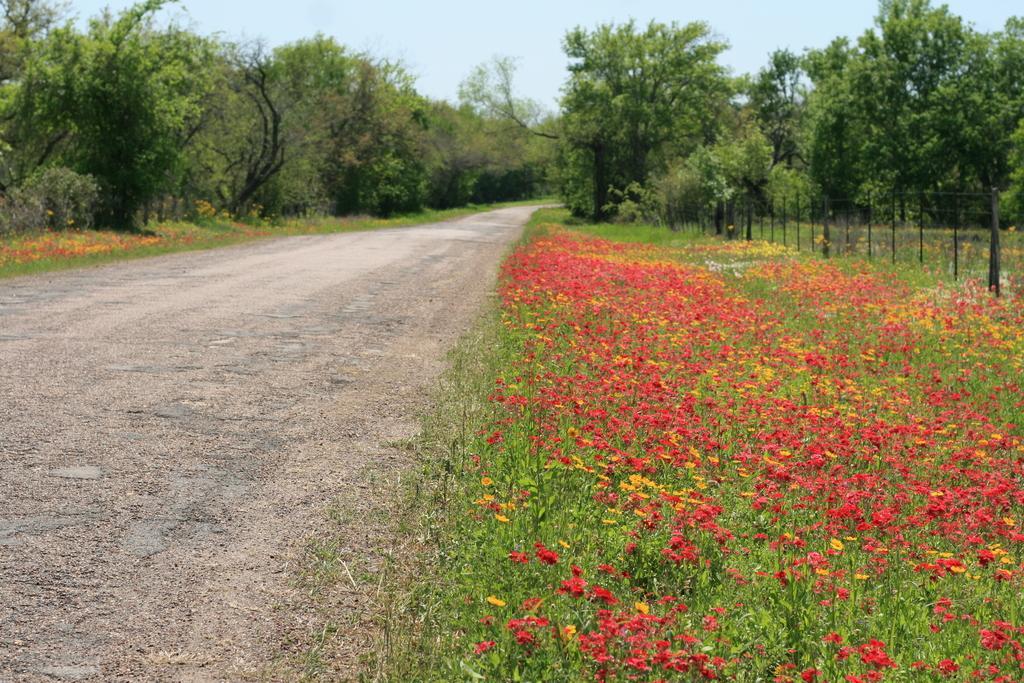Describe this image in one or two sentences. In the background we can see the sky. In this picture we can see the trees, flowers, plants. On the right side of the picture we can see the fence. On the left side of the picture we can see the road. 